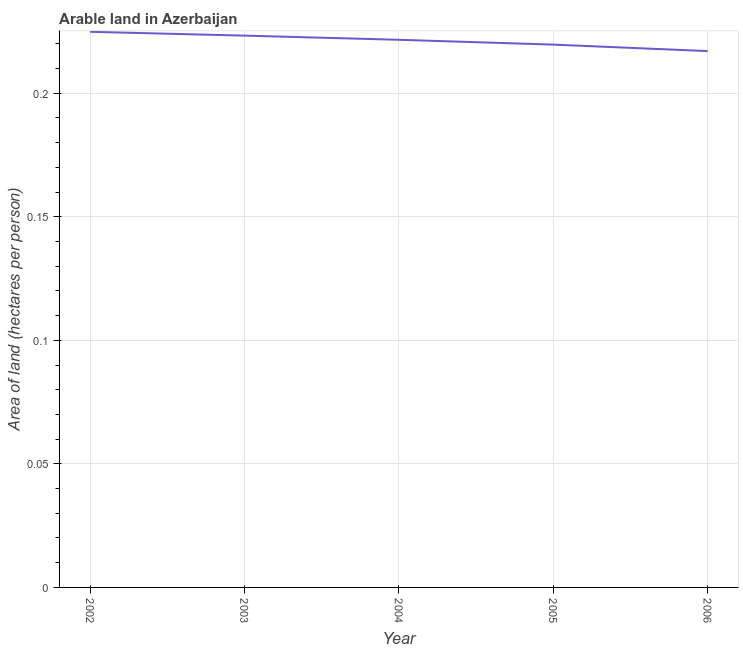What is the area of arable land in 2002?
Your response must be concise. 0.22. Across all years, what is the maximum area of arable land?
Your response must be concise. 0.22. Across all years, what is the minimum area of arable land?
Your answer should be very brief. 0.22. In which year was the area of arable land maximum?
Ensure brevity in your answer.  2002. What is the sum of the area of arable land?
Make the answer very short. 1.11. What is the difference between the area of arable land in 2002 and 2005?
Provide a short and direct response. 0.01. What is the average area of arable land per year?
Keep it short and to the point. 0.22. What is the median area of arable land?
Ensure brevity in your answer.  0.22. In how many years, is the area of arable land greater than 0.03 hectares per person?
Offer a terse response. 5. What is the ratio of the area of arable land in 2002 to that in 2004?
Give a very brief answer. 1.01. Is the difference between the area of arable land in 2004 and 2006 greater than the difference between any two years?
Your answer should be compact. No. What is the difference between the highest and the second highest area of arable land?
Ensure brevity in your answer.  0. What is the difference between the highest and the lowest area of arable land?
Your answer should be compact. 0.01. How many lines are there?
Ensure brevity in your answer.  1. How many years are there in the graph?
Provide a succinct answer. 5. Does the graph contain grids?
Ensure brevity in your answer.  Yes. What is the title of the graph?
Keep it short and to the point. Arable land in Azerbaijan. What is the label or title of the X-axis?
Give a very brief answer. Year. What is the label or title of the Y-axis?
Your answer should be very brief. Area of land (hectares per person). What is the Area of land (hectares per person) of 2002?
Offer a terse response. 0.22. What is the Area of land (hectares per person) of 2003?
Your response must be concise. 0.22. What is the Area of land (hectares per person) of 2004?
Make the answer very short. 0.22. What is the Area of land (hectares per person) in 2005?
Keep it short and to the point. 0.22. What is the Area of land (hectares per person) in 2006?
Offer a terse response. 0.22. What is the difference between the Area of land (hectares per person) in 2002 and 2003?
Ensure brevity in your answer.  0. What is the difference between the Area of land (hectares per person) in 2002 and 2004?
Offer a terse response. 0. What is the difference between the Area of land (hectares per person) in 2002 and 2005?
Offer a very short reply. 0.01. What is the difference between the Area of land (hectares per person) in 2002 and 2006?
Make the answer very short. 0.01. What is the difference between the Area of land (hectares per person) in 2003 and 2004?
Your answer should be compact. 0. What is the difference between the Area of land (hectares per person) in 2003 and 2005?
Your answer should be very brief. 0. What is the difference between the Area of land (hectares per person) in 2003 and 2006?
Your answer should be compact. 0.01. What is the difference between the Area of land (hectares per person) in 2004 and 2005?
Keep it short and to the point. 0. What is the difference between the Area of land (hectares per person) in 2004 and 2006?
Make the answer very short. 0. What is the difference between the Area of land (hectares per person) in 2005 and 2006?
Your answer should be very brief. 0. What is the ratio of the Area of land (hectares per person) in 2002 to that in 2003?
Offer a very short reply. 1.01. What is the ratio of the Area of land (hectares per person) in 2002 to that in 2005?
Provide a short and direct response. 1.02. What is the ratio of the Area of land (hectares per person) in 2002 to that in 2006?
Offer a very short reply. 1.04. What is the ratio of the Area of land (hectares per person) in 2003 to that in 2004?
Offer a terse response. 1.01. What is the ratio of the Area of land (hectares per person) in 2003 to that in 2005?
Provide a short and direct response. 1.02. What is the ratio of the Area of land (hectares per person) in 2005 to that in 2006?
Provide a short and direct response. 1.01. 